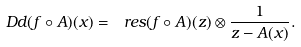<formula> <loc_0><loc_0><loc_500><loc_500>\ D d ( f \circ A ) ( x ) = \ r e s ( f \circ A ) ( z ) \otimes \frac { 1 } { z - A ( x ) } .</formula> 